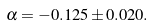Convert formula to latex. <formula><loc_0><loc_0><loc_500><loc_500>\alpha = - 0 . 1 2 5 \pm 0 . 0 2 0 .</formula> 